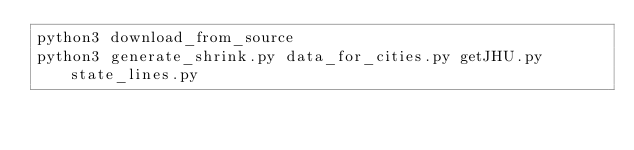Convert code to text. <code><loc_0><loc_0><loc_500><loc_500><_Bash_>python3 download_from_source
python3 generate_shrink.py data_for_cities.py getJHU.py state_lines.py</code> 